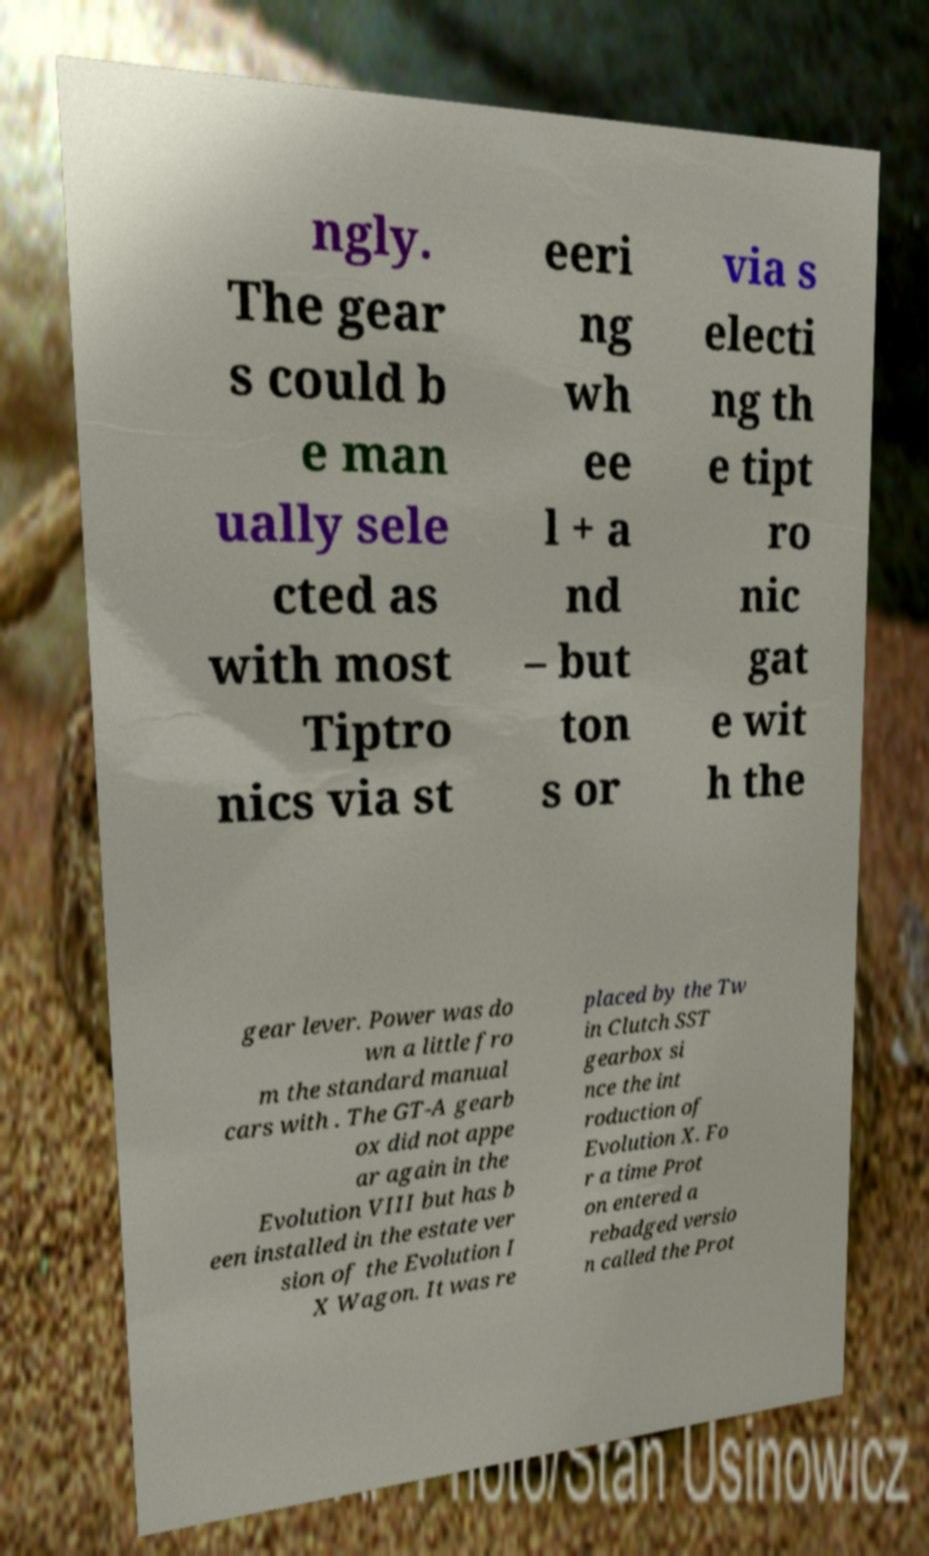Please read and relay the text visible in this image. What does it say? ngly. The gear s could b e man ually sele cted as with most Tiptro nics via st eeri ng wh ee l + a nd – but ton s or via s electi ng th e tipt ro nic gat e wit h the gear lever. Power was do wn a little fro m the standard manual cars with . The GT-A gearb ox did not appe ar again in the Evolution VIII but has b een installed in the estate ver sion of the Evolution I X Wagon. It was re placed by the Tw in Clutch SST gearbox si nce the int roduction of Evolution X. Fo r a time Prot on entered a rebadged versio n called the Prot 